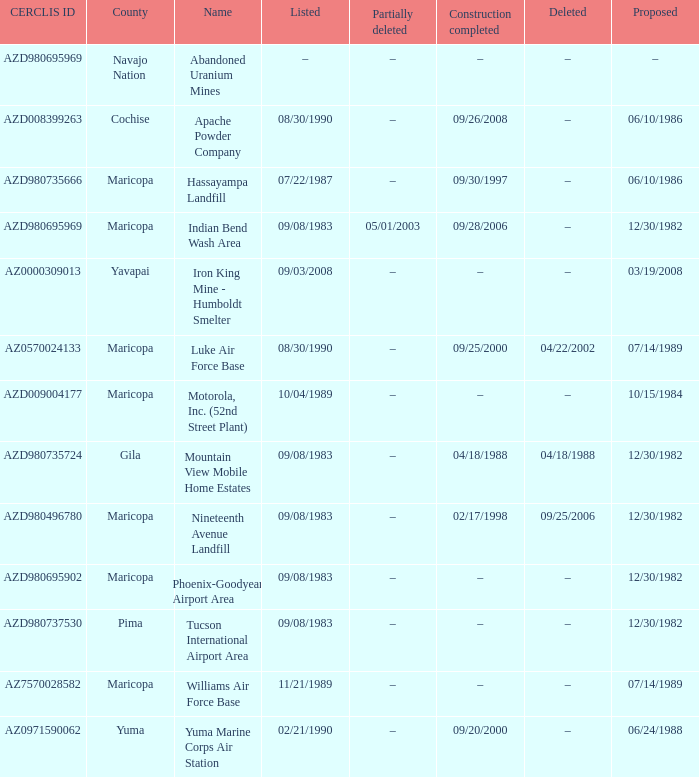What is the cerclis id when the site was proposed on 12/30/1982 and was partially deleted on 05/01/2003? AZD980695969. 